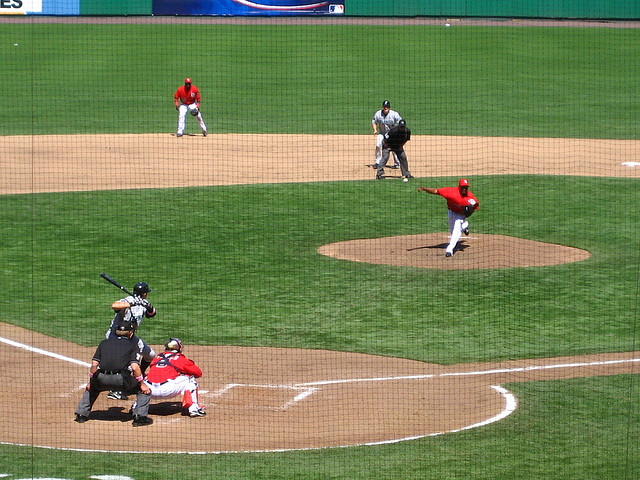How many people are there? There are exactly six people visible in the image, including the batter, catcher, pitcher, umpire, and two players in the field. 